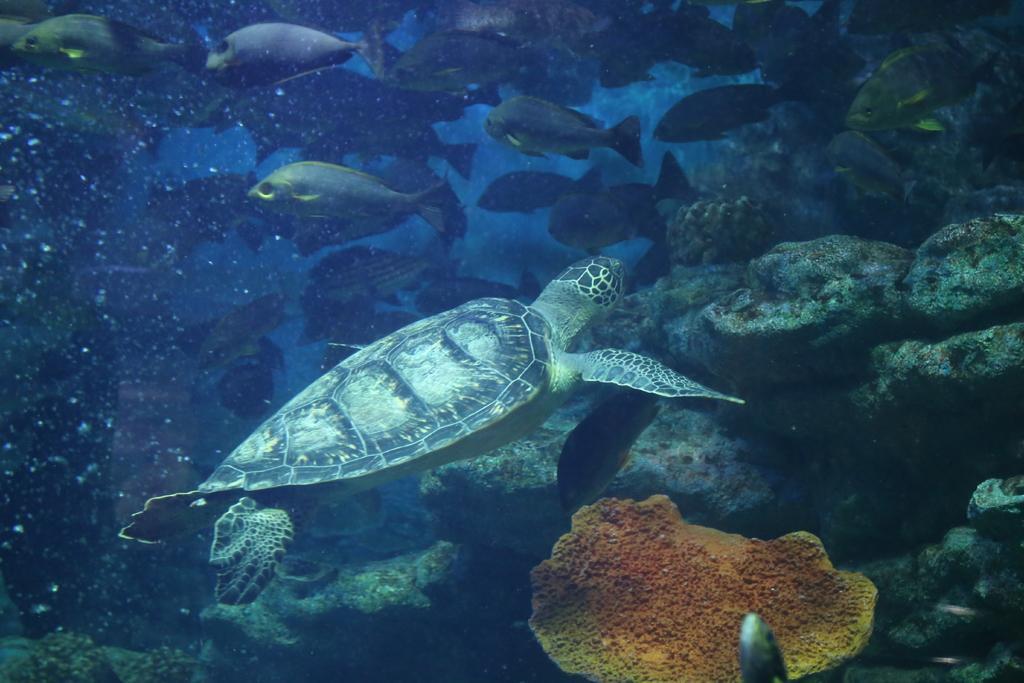Please provide a concise description of this image. In this picture we can see some fishes and a turtle, we can see under water environment, on the right side there are some stones. 